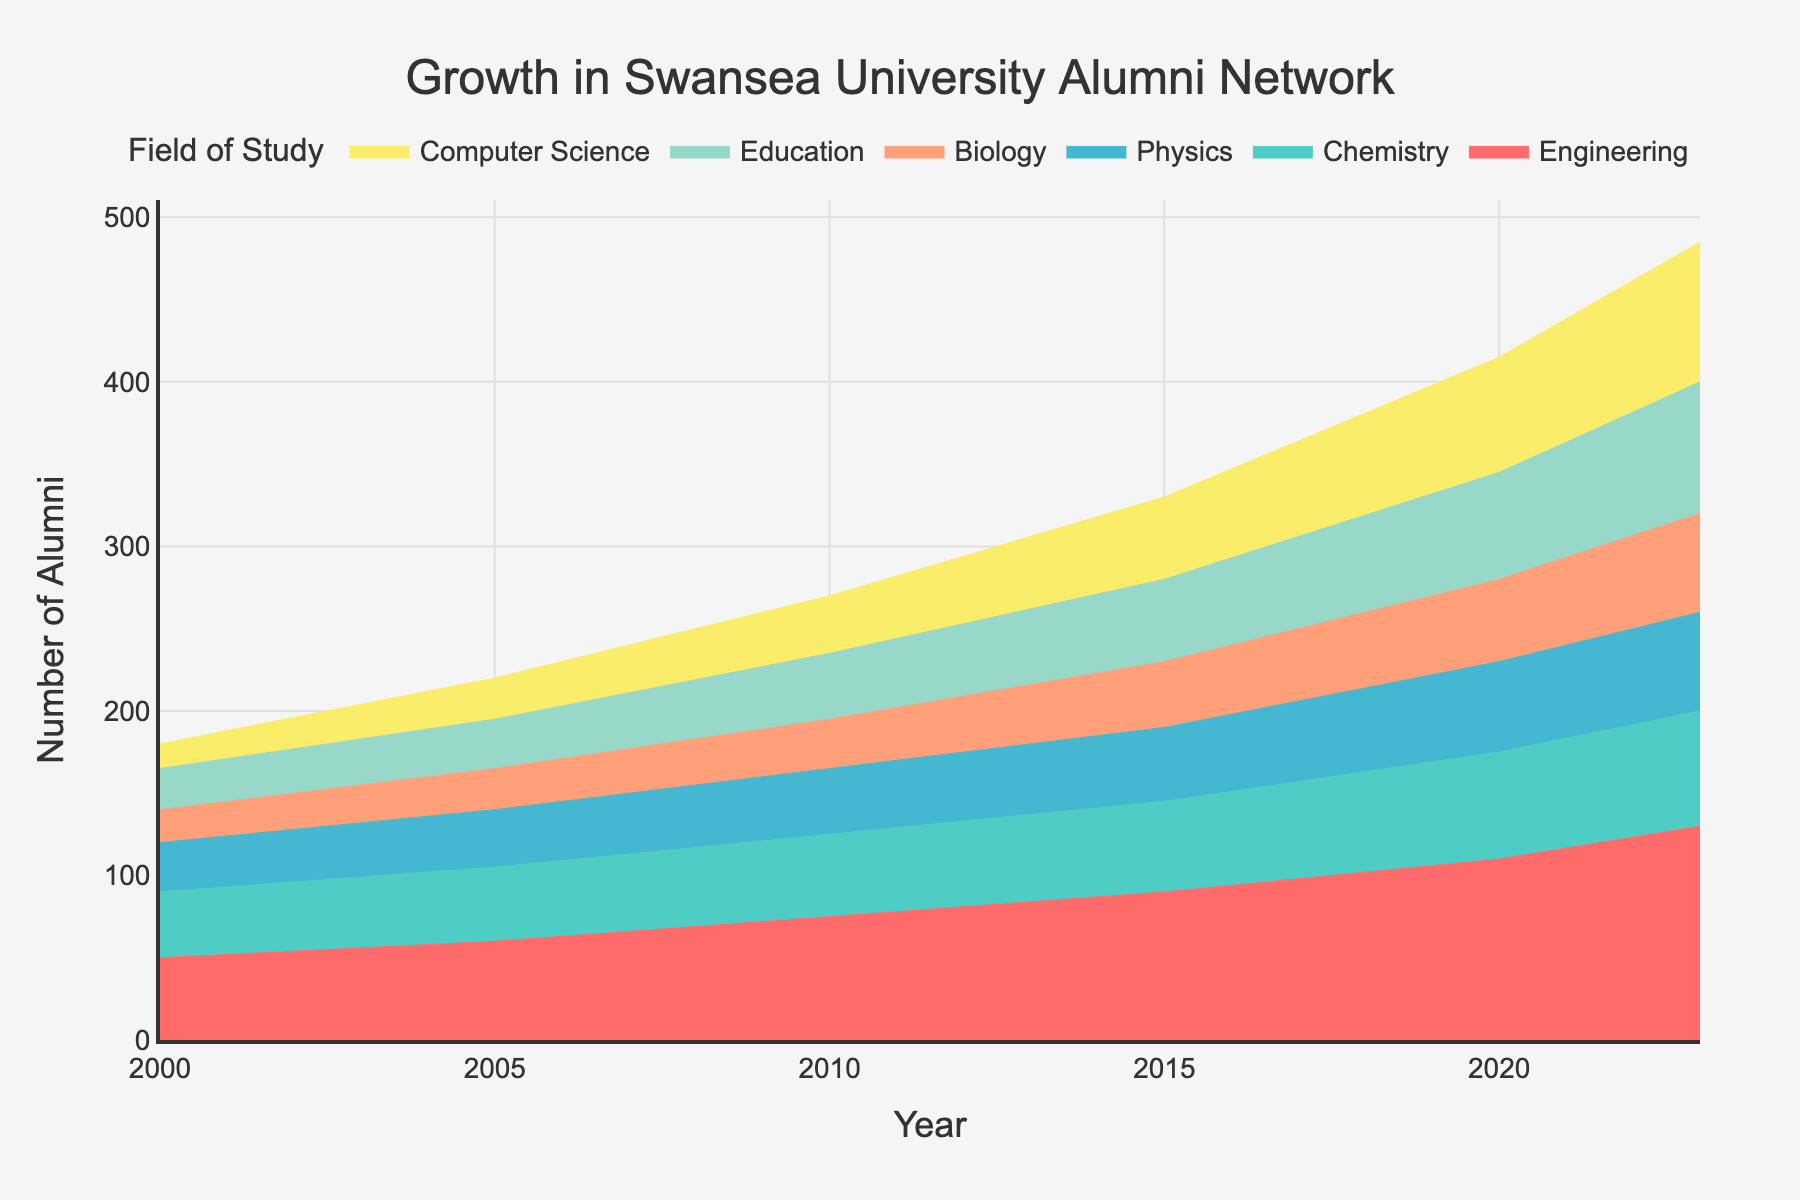What is the overall trend in the number of Engineering alumni from 2000 to 2023? The area chart shows a steady increase in Engineering alumni from approximately 50 in 2000 to about 130 in 2023, indicating continuous growth over the years.
Answer: Continuous growth What is the total number of Chemistry alumni in the year 2020? By looking at the area corresponding to Chemistry in the year 2020, it is clear that the number has reached around 65 alumni.
Answer: 65 Which field of study had the most significant increase in alumni numbers from 2000 to 2023? By comparing the height of the areas for each field of study in 2000 and 2023, we can see that Computer Science had the most significant increase, growing from 15 alumni in 2000 to 85 alumni in 2023, an increase of 70 alumni.
Answer: Computer Science How many more Biology alumni were there in 2023 compared to 2000? The number of Biology alumni in 2000 was approximately 20, and in 2023 it was about 60. Therefore, the increase is 60 - 20 = 40.
Answer: 40 What field of study had the least number of alumni in the year 2000, and how many were there? By examining the area chart for the year 2000, Computer Science has the smallest area, indicating it had the least number of alumni, specifically around 15.
Answer: Computer Science, 15 How does the growth in the number of Education alumni compare with that in Physics from 2000 to 2023? Education saw a rise from 25 to 80 alumni (an increase of 55), whereas Physics increased from 30 to 60 alumni (an increase of 30). Therefore, Education experienced a more significant growth in alumni numbers compared to Physics.
Answer: Education grew more than Physics What are the two fields with the highest number of alumni in 2023? Observing the areas for the year 2023, Engineering and Education have the highest number of alumni with approximately 130 and 80 alumni, respectively.
Answer: Engineering and Education How has the number of alumni in Chemistry changed between 2010 and 2015? The chart shows the number of Chemistry alumni increased from 50 in 2010 to 55 in 2015, which is an increase of 5 alumni.
Answer: Increased by 5 Which field experienced the least growth from 2000 to 2023, and what is the increase? Comparing the growth of all fields, Physics increased from 30 to 60 alumni, which is an increase of 30 and is the smallest among the fields.
Answer: Physics, increased by 30 How does the alumni trend in fields of study (like Engineering and Chemistry) help in understanding the popularity of these fields over the years? By observing the continuous and notable increase in alumni in fields like Engineering and Chemistry, we can infer these fields have grown in popularity and have attracted more students over the years. The data shows consistent growth, reflecting a sustained interest.
Answer: Reflects sustained interest 